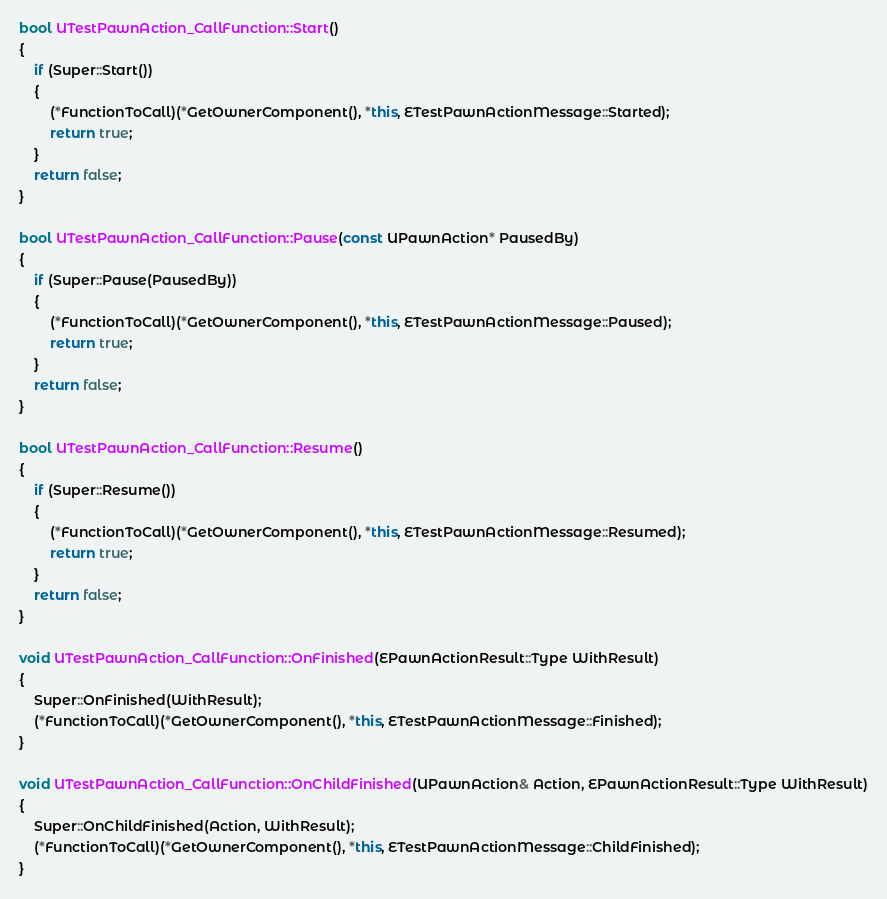Convert code to text. <code><loc_0><loc_0><loc_500><loc_500><_C++_>bool UTestPawnAction_CallFunction::Start()
{
	if (Super::Start())
	{
		(*FunctionToCall)(*GetOwnerComponent(), *this, ETestPawnActionMessage::Started);
		return true;
	}
	return false;
}

bool UTestPawnAction_CallFunction::Pause(const UPawnAction* PausedBy)
{
	if (Super::Pause(PausedBy))
	{
		(*FunctionToCall)(*GetOwnerComponent(), *this, ETestPawnActionMessage::Paused);
		return true;
	}
	return false;
}

bool UTestPawnAction_CallFunction::Resume()
{
	if (Super::Resume())
	{
		(*FunctionToCall)(*GetOwnerComponent(), *this, ETestPawnActionMessage::Resumed);
		return true;
	}
	return false;
}

void UTestPawnAction_CallFunction::OnFinished(EPawnActionResult::Type WithResult)
{
	Super::OnFinished(WithResult);
	(*FunctionToCall)(*GetOwnerComponent(), *this, ETestPawnActionMessage::Finished);
}

void UTestPawnAction_CallFunction::OnChildFinished(UPawnAction& Action, EPawnActionResult::Type WithResult)
{
	Super::OnChildFinished(Action, WithResult);
	(*FunctionToCall)(*GetOwnerComponent(), *this, ETestPawnActionMessage::ChildFinished);
}
</code> 